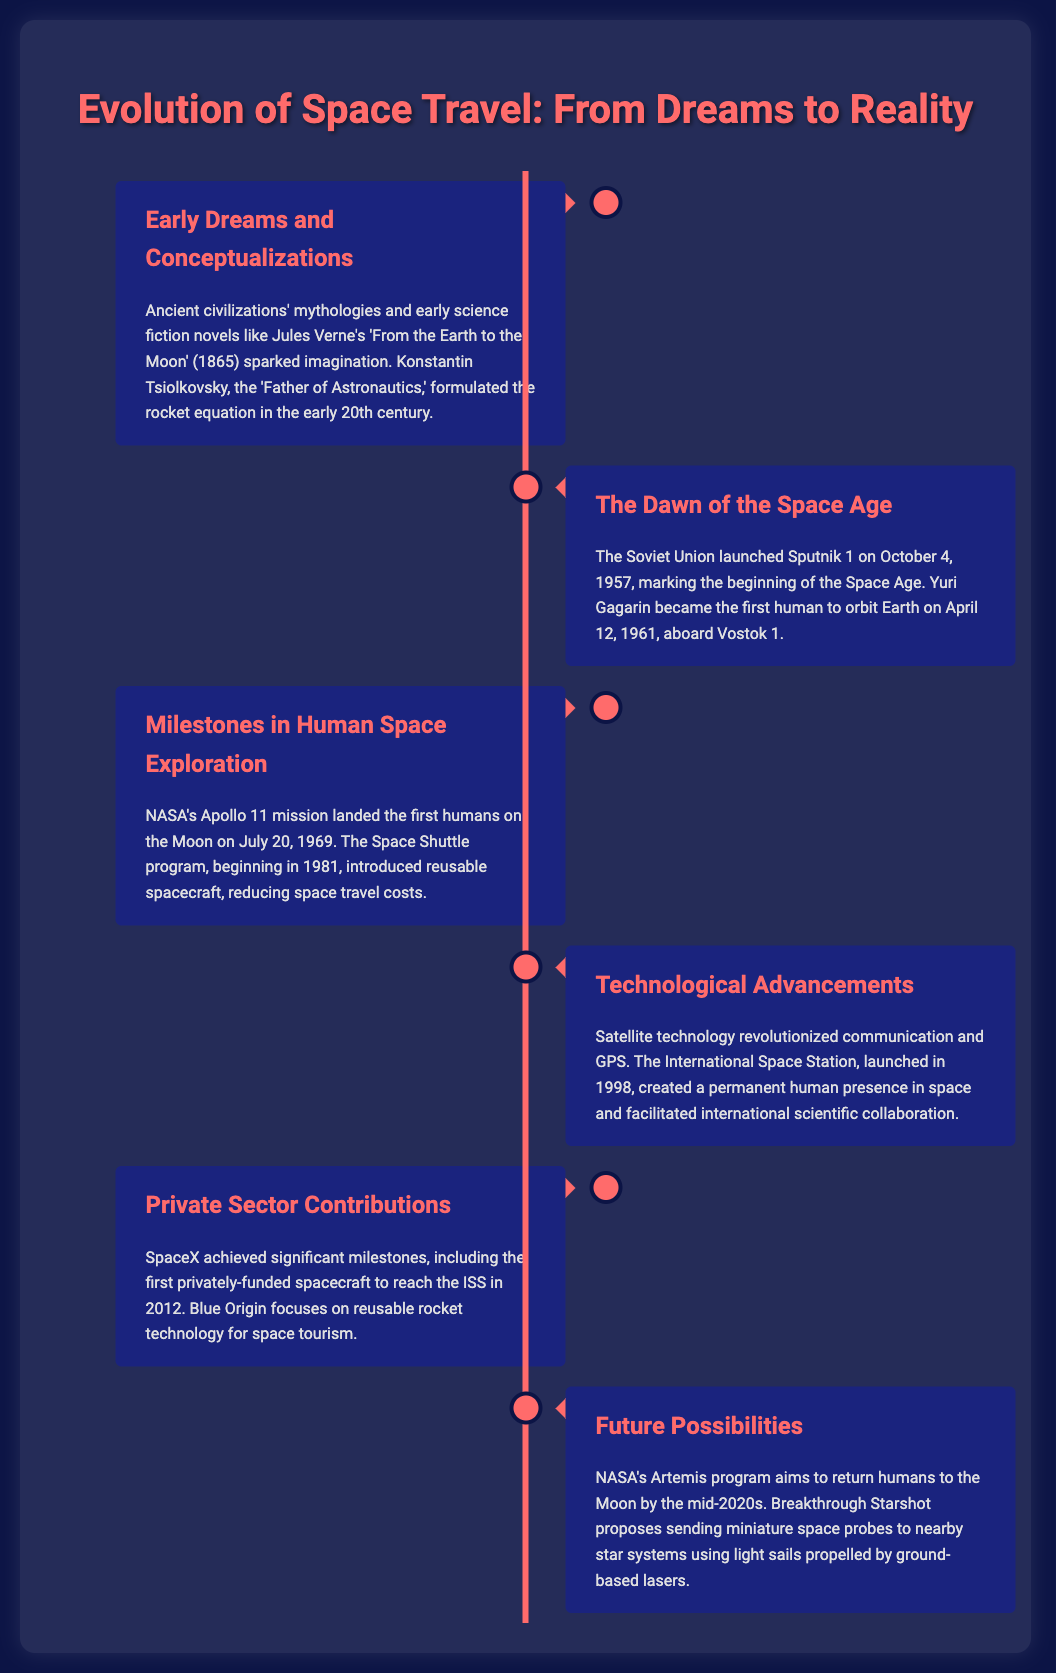What was the first human to orbit Earth? The document states that Yuri Gagarin became the first human to orbit Earth on April 12, 1961.
Answer: Yuri Gagarin When did Apollo 11 land on the Moon? The document mentions that Apollo 11 landed the first humans on the Moon on July 20, 1969.
Answer: July 20, 1969 What program aims to return humans to the Moon by the mid-2020s? According to the document, NASA's Artemis program aims to return humans to the Moon by the mid-2020s.
Answer: Artemis program Which rocket company first reached the ISS? The document states that SpaceX achieved the milestone of being the first privately-funded spacecraft to reach the ISS in 2012.
Answer: SpaceX What key technological advancement began in 1981? The document indicates that the Space Shuttle program began in 1981.
Answer: Space Shuttle program Which light propulsion strategy does Breakthrough Starshot propose? The document mentions that Breakthrough Starshot proposes sending miniature space probes using light sails propelled by ground-based lasers.
Answer: Light sails Who is known as the 'Father of Astronautics'? The document identifies Konstantin Tsiolkovsky as the 'Father of Astronautics'.
Answer: Konstantin Tsiolkovsky What year did the Soviet Union launch Sputnik 1? The document states that Sputnik 1 was launched on October 4, 1957.
Answer: 1957 What international facility was launched in 1998? The document refers to the International Space Station, which was launched in 1998.
Answer: International Space Station 